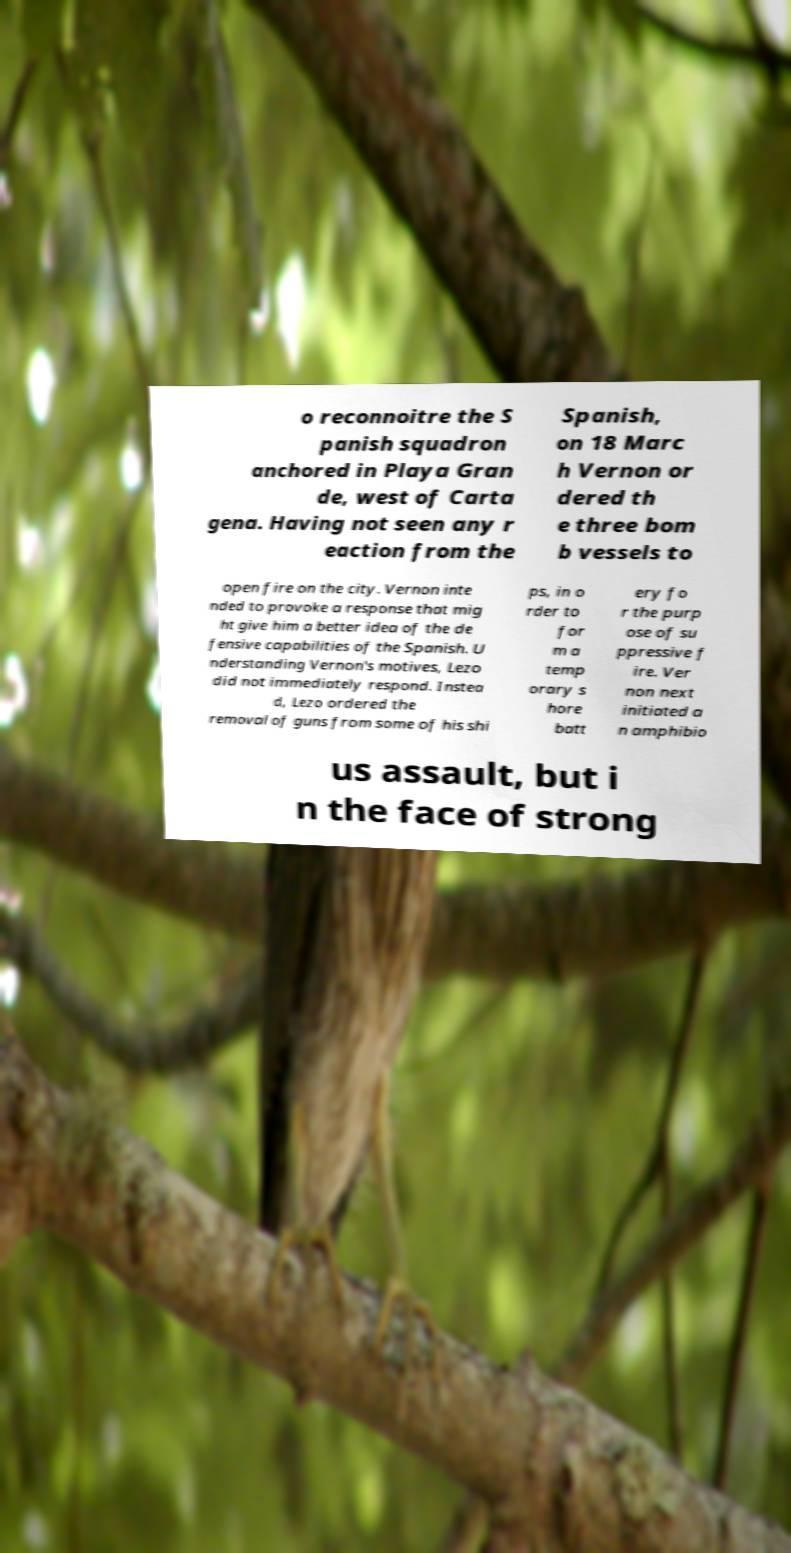What messages or text are displayed in this image? I need them in a readable, typed format. o reconnoitre the S panish squadron anchored in Playa Gran de, west of Carta gena. Having not seen any r eaction from the Spanish, on 18 Marc h Vernon or dered th e three bom b vessels to open fire on the city. Vernon inte nded to provoke a response that mig ht give him a better idea of the de fensive capabilities of the Spanish. U nderstanding Vernon's motives, Lezo did not immediately respond. Instea d, Lezo ordered the removal of guns from some of his shi ps, in o rder to for m a temp orary s hore batt ery fo r the purp ose of su ppressive f ire. Ver non next initiated a n amphibio us assault, but i n the face of strong 